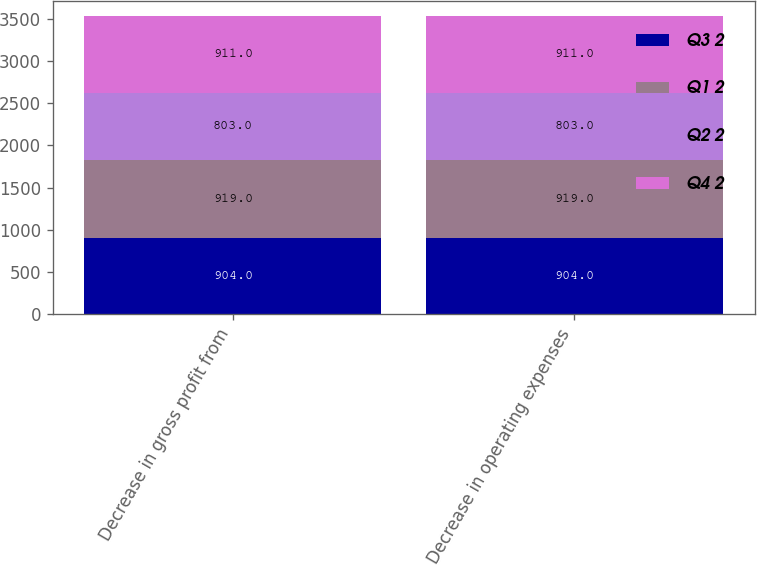Convert chart. <chart><loc_0><loc_0><loc_500><loc_500><stacked_bar_chart><ecel><fcel>Decrease in gross profit from<fcel>Decrease in operating expenses<nl><fcel>Q3 2<fcel>904<fcel>904<nl><fcel>Q1 2<fcel>919<fcel>919<nl><fcel>Q2 2<fcel>803<fcel>803<nl><fcel>Q4 2<fcel>911<fcel>911<nl></chart> 